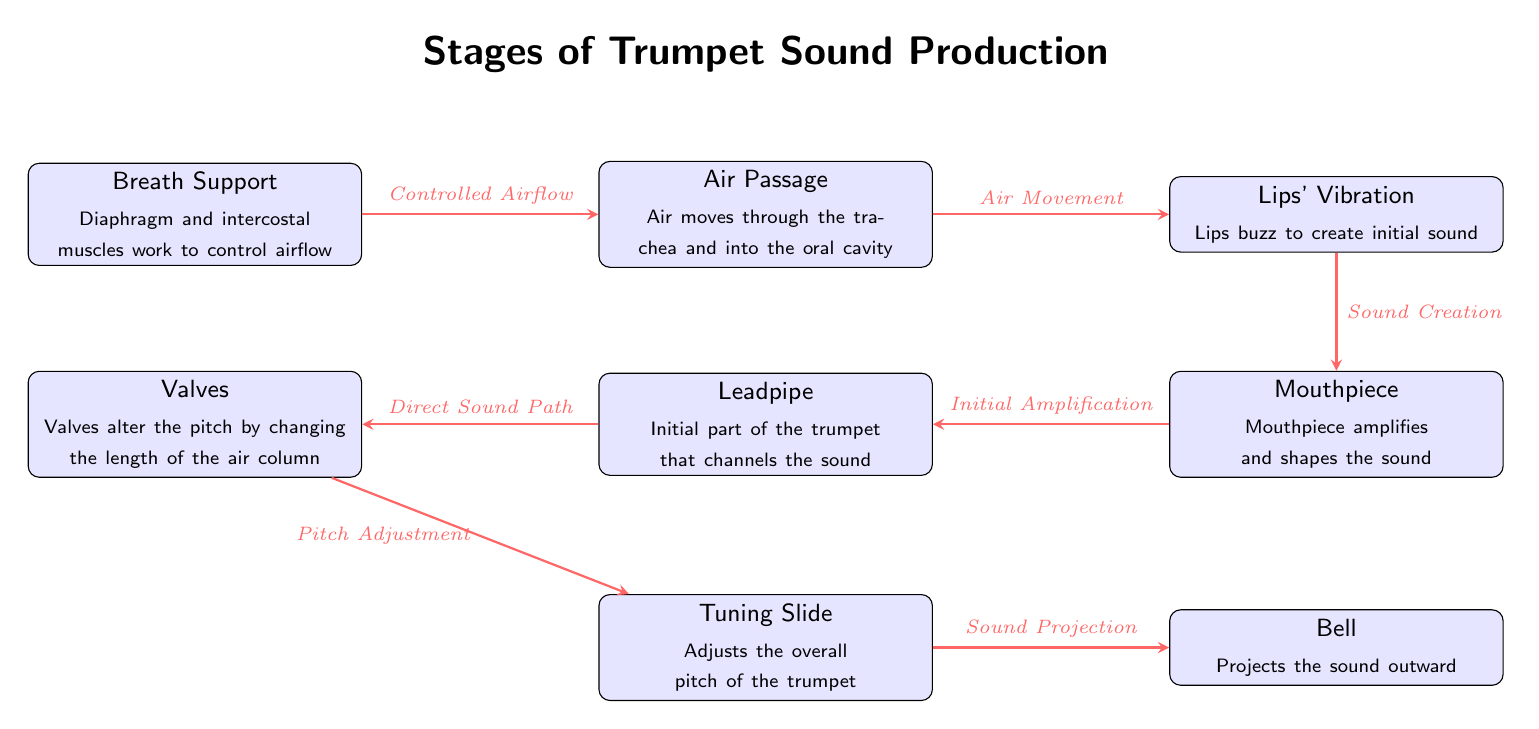What are the parts involved in trumpet sound production? The diagram lists eight parts involved in trumpet sound production: Breath Support, Air Passage, Lips' Vibration, Mouthpiece, Leadpipe, Valves, Tuning Slide, and Bell.
Answer: Eight parts What does the arrow from "Controlled Airflow" to "Air Movement" signify? The arrow indicates the movement of air from the Breath Support to the Air Passage, emphasizing the control of airflow as it transitions into the next stage.
Answer: Air Movement Which part is responsible for adjusting the overall pitch of the trumpet? According to the diagram, the Tuning Slide is specifically mentioned as the component that adjusts the overall pitch of the trumpet.
Answer: Tuning Slide What is the function of the Mouthpiece in the sound production process? The Mouthpiece has the function of amplifying and shaping the sound, as indicated in its annotation in the diagram.
Answer: Amplifies and shapes How does the sound creation process start? The sound creation process starts with the Lips' Vibration, where the lips buzz to create the initial sound as the air moves through.
Answer: Lips buzz What is the relationship between the Valves and the Pitch Adjustment? The Valves interact with the Tuning Slide by altering the pitch, as they change the length of the air column, which affects the pitch produced by the trumpet.
Answer: Alter the pitch How many arrows are present in the diagram? A count of the arrows in the diagram reveals that there are seven arrows connecting the nodes, indicating the flow of the sound production stages.
Answer: Seven arrows What nodes directly lead into the Bell? The Bell receives sound input from the Tuning Slide, as indicated by the arrow pointing from Tuning Slide to Bell in the diagram.
Answer: Tuning Slide What does the Leadpipe channel? The Leadpipe channels the sound as indicated in its description, which states that it is the initial part of the trumpet that directs the sound.
Answer: Channels the sound 